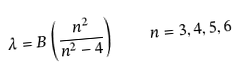Convert formula to latex. <formula><loc_0><loc_0><loc_500><loc_500>\lambda = B \left ( { \frac { n ^ { 2 } } { n ^ { 2 } - 4 } } \right ) \quad n = 3 , 4 , 5 , 6</formula> 